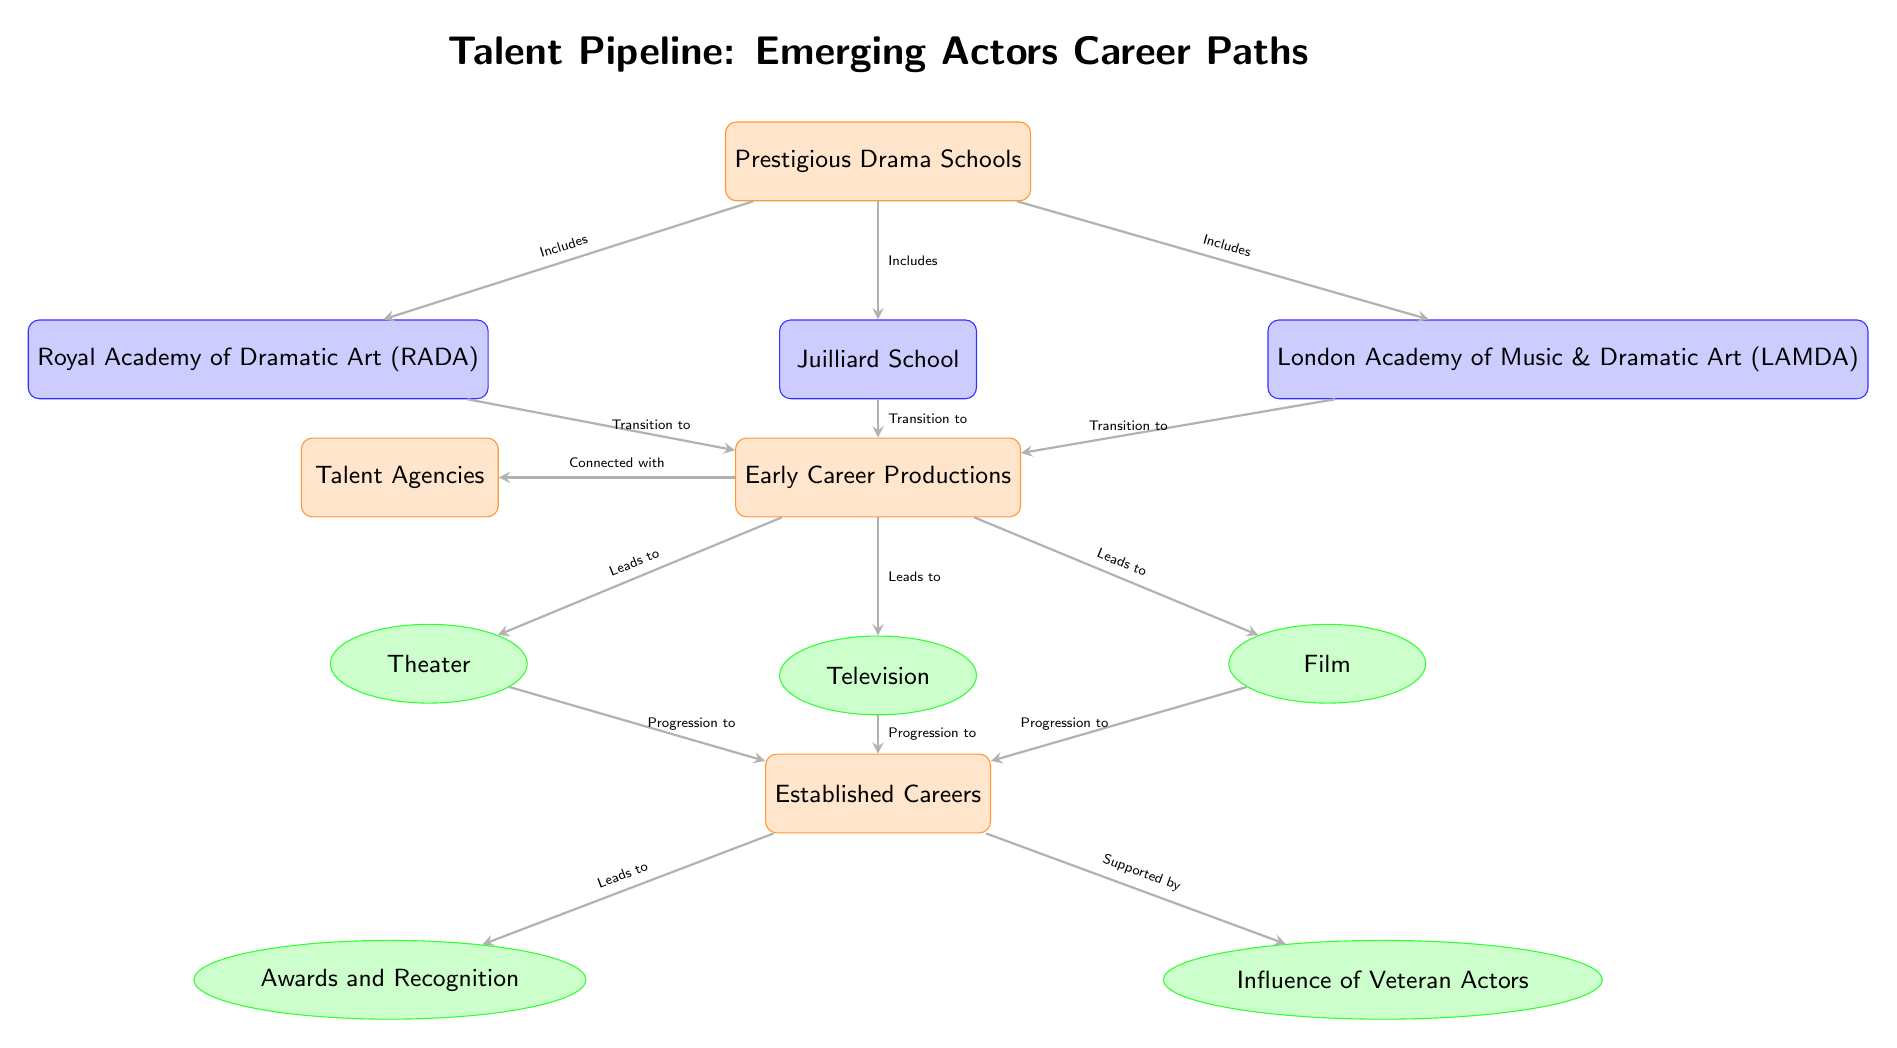What are the three prestigious drama schools listed in the diagram? The diagram directly lists the schools: Royal Academy of Dramatic Art, Juilliard School, and London Academy of Music & Dramatic Art.
Answer: Royal Academy of Dramatic Art, Juilliard School, London Academy of Music & Dramatic Art Which type of productions do emerging actors transition to? The diagram shows that emerging actors transition to Early Career Productions, and further, this connects to Theater, Television, and Film.
Answer: Early Career Productions How many career paths are shown under Established Careers? The diagram shows two career paths listed under Established Careers: Awards and Recognition, and Influence of Veteran Actors.
Answer: 2 What do Early Career Productions lead to? The diagram indicates that Early Career Productions lead to Theater, Television, and Film, which are given in a single branching pathway below it.
Answer: Theater, Television, Film What is the main connection between Talent Agencies and Early Career Productions? The diagram indicates that Talent Agencies are connected with Early Career Productions through an arrow labeled "Connected with," showing that agencies play a role in these productions.
Answer: Connected with What can be inferred about the relationship between Established Careers and Awards and Recognition? The diagram indicates that Established Careers lead to Awards and Recognition, inferring that there is a direct progression from having an established career to receiving awards.
Answer: Leads to Which node represents the transition point from drama schools to early career productions? Based on the structure of the diagram, the transition point is represented by the node labeled Early Career Productions, which is directly shown below the drama schools node.
Answer: Early Career Productions How does the role of veteran actors influence emerging actors' careers? The diagram depicts that the influence of veteran actors is a supported aspect of established careers, indicating that they play a significant role in shaping these careers.
Answer: Supported by 